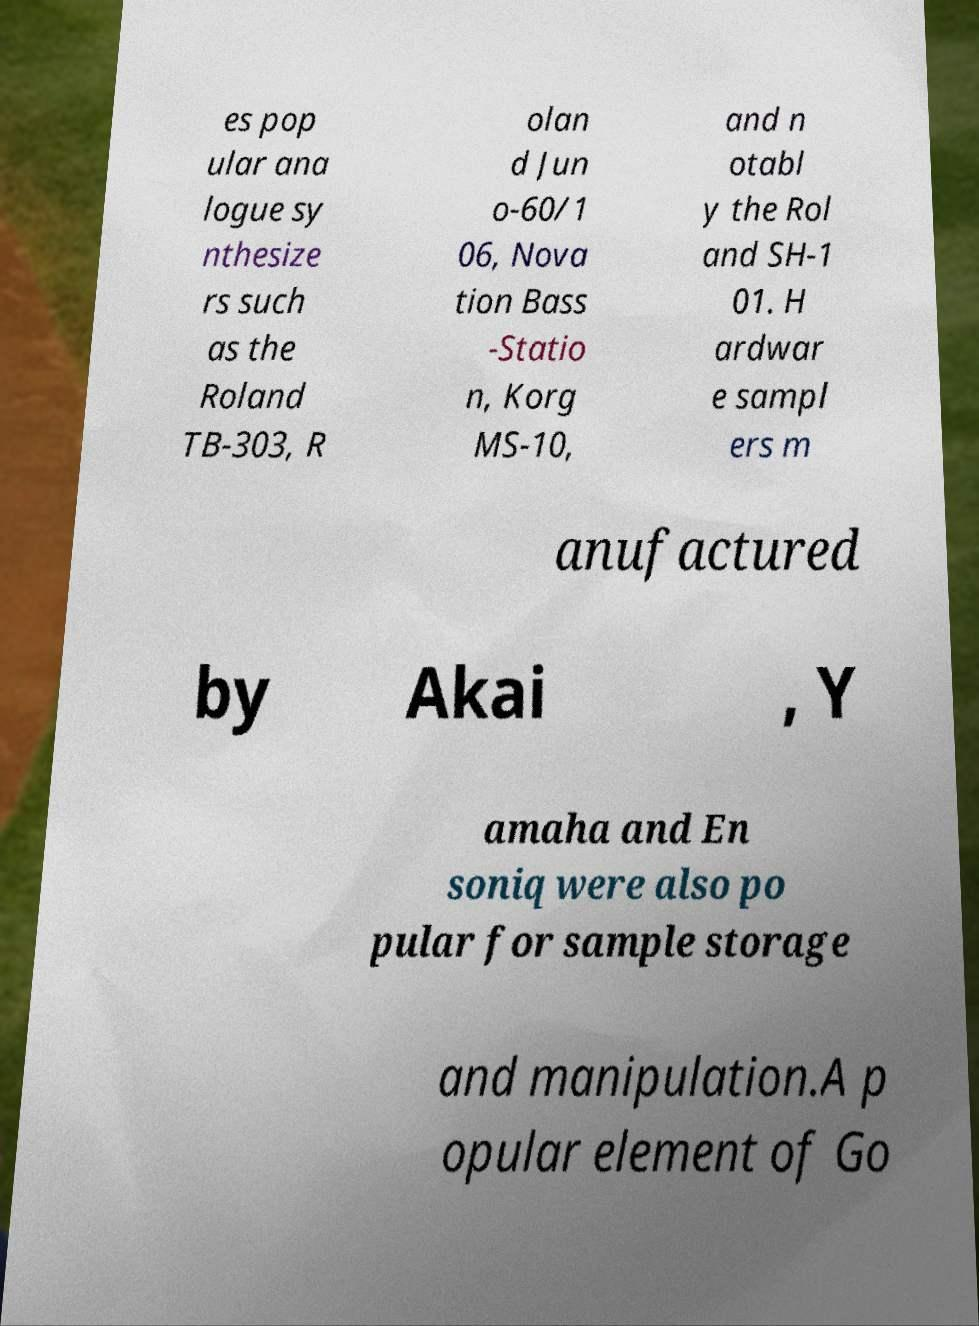There's text embedded in this image that I need extracted. Can you transcribe it verbatim? es pop ular ana logue sy nthesize rs such as the Roland TB-303, R olan d Jun o-60/1 06, Nova tion Bass -Statio n, Korg MS-10, and n otabl y the Rol and SH-1 01. H ardwar e sampl ers m anufactured by Akai , Y amaha and En soniq were also po pular for sample storage and manipulation.A p opular element of Go 